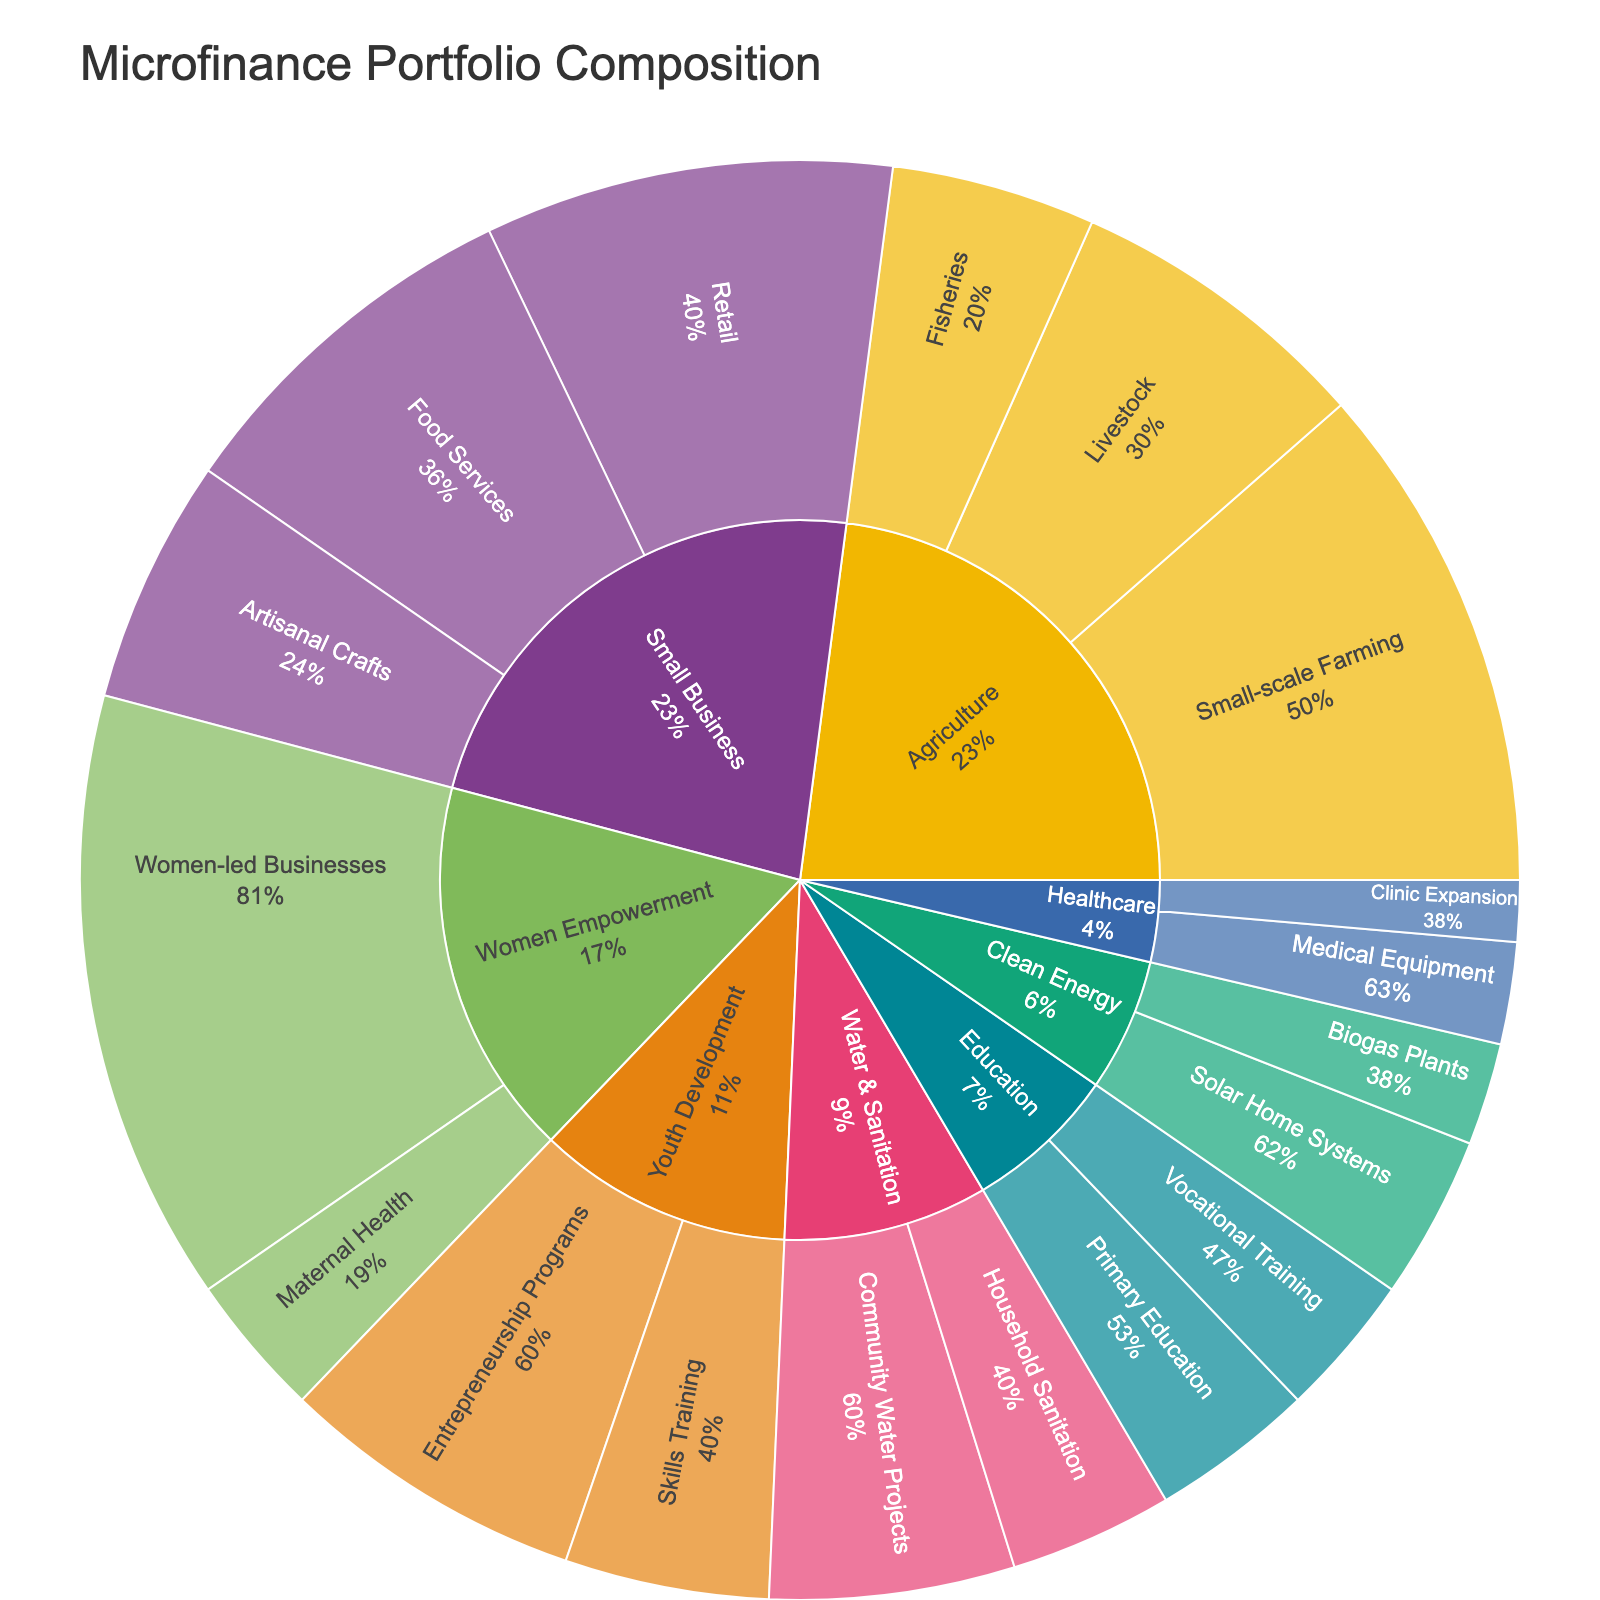What is the title of the figure? The title of a figure is usually positioned at the top and is the largest text element in the plot. By looking at the top of the figure, you can read the title.
Answer: Microfinance Portfolio Composition How many categories are represented in the sunburst plot? The sunburst plot uses different sections for each category, typically differentiated by colors. Each main segment extending from the center represents a category. By counting these segments, you can find the number of categories.
Answer: 8 Which loan type has the highest value in the Women Empowerment category? The sectors within the Women Empowerment category are represented by segments extending outward. By comparing the lengths of these segments, you can identify the one with the highest value.
Answer: Women-led Businesses What is the combined value of subcategories in the Agriculture category? To find the combined value, sum the values given for each subcategory within the Agriculture category. The values are: Small-scale Farming (25), Livestock (15), and Fisheries (10). Thus, the combined value is 25 + 15 + 10 = 50.
Answer: 50 How does the value of Retail in Small Business compare to the value of Entrepreneurship Programs in Youth Development? Identify the segments for Retail and Entrepreneurship Programs. Then compare their values directly. Retail has a value of 20, and Entrepreneurship Programs have a value of 15. Retail is greater than Entrepreneurship Programs.
Answer: Retail > Entrepreneurship Programs Which category has the smallest individual subcategory value, and what is that value? Look through each category and find the smallest segment. The subcategory with the smallest value is Clinic Expansion in Healthcare, with a value of 3. This is the smallest individual value across all categories.
Answer: Clinic Expansion, 3 What percentage of the total value does the Small Business category contribute? First, sum the total values of all categories. The values for Small Business are Retail (20), Artisanal Crafts (12), and Food Services (18), for a total of 20 + 12 + 18 = 50. The sum of all values across the entire plot is 208. Calculate the percentage as (50 / 208) * 100%.
Answer: 24.0% How many subcategories are there in total within the sunburst plot? Each subcategory is represented as a segment branching out from its respective category. By counting all segments, you find the total number of subcategories.
Answer: 18 Which category has the broadest range of subcategory values? To find the range of subcategory values within each category, calculate the difference between the highest and lowest values for each category. The Women Empowerment category has the broadest range from 30 (Women-led Businesses) to 7 (Maternal Health), giving a range of 23.
Answer: Women Empowerment 